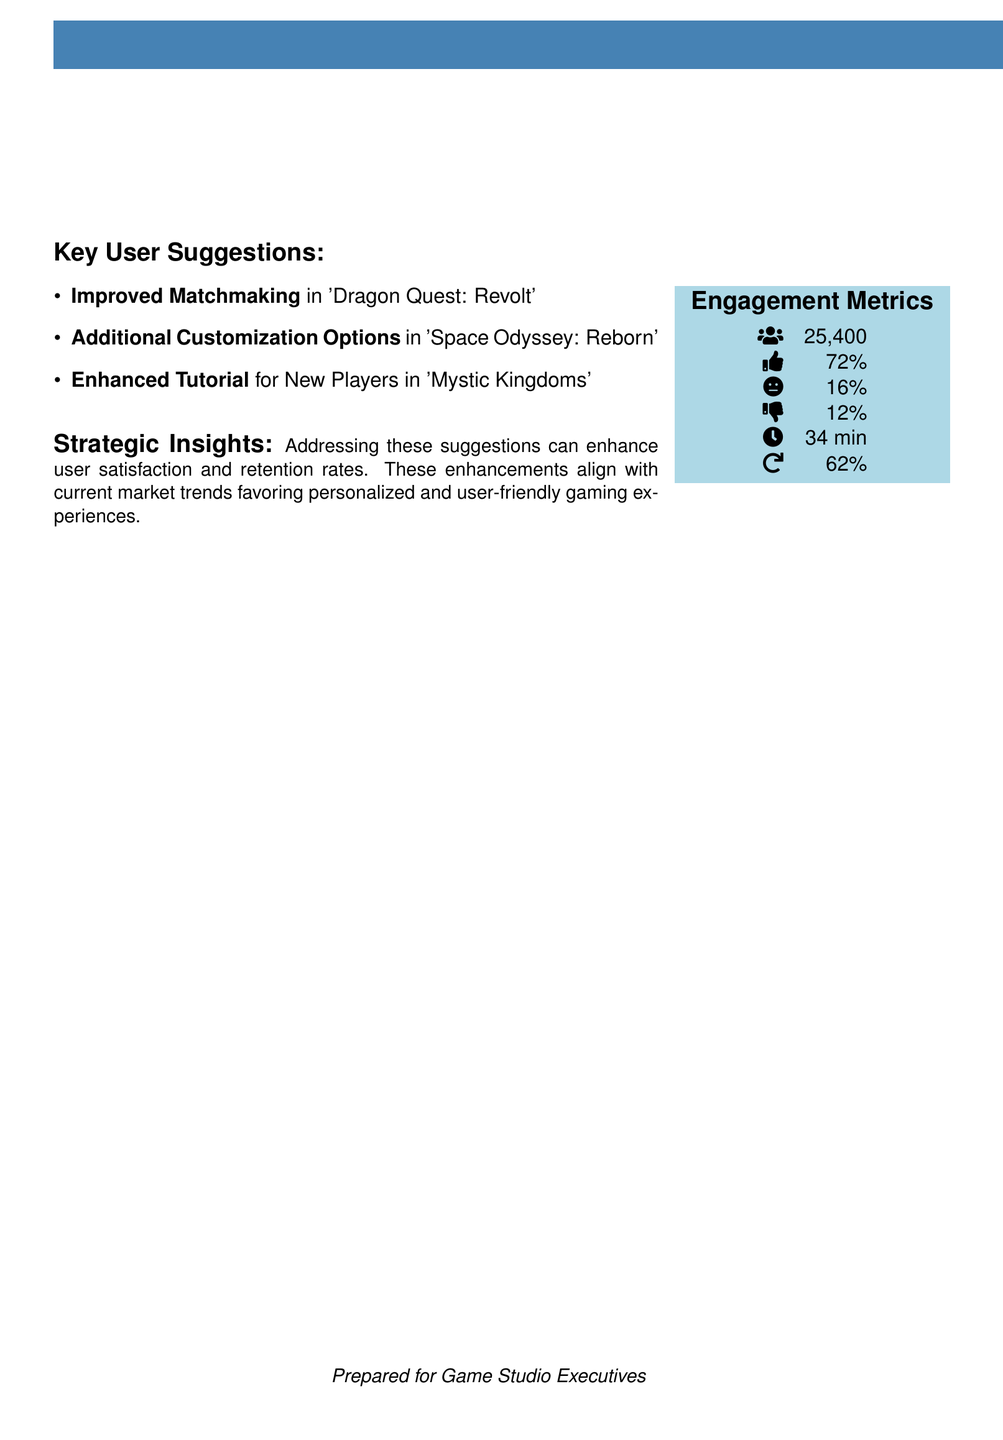What is the title of the report? The title of the report is presented at the top of the document, indicating the focus on user feedback.
Answer: User Feedback Report Q3 2023 How many users provided feedback? The number of users is listed under engagement metrics, representing the total participant count for feedback.
Answer: 25,400 What percentage of users liked the game? This percentage is shown in the engagement metrics, indicating user satisfaction levels.
Answer: 72% What is one key user suggestion related to 'Dragon Quest: Revolt'? The suggestions for improvement in the game are explicitly listed in the document.
Answer: Improved Matchmaking What engagement metric indicates session duration? This metric is specifically noted in the engagement section, reflecting the average time users spend on the game.
Answer: 34 min What is the percentage of neutral feedback? The document outlines user sentiment, including neutral feedback metrics in the engagement section.
Answer: 16% What is the suggested improvement for 'Mystic Kingdoms'? The suggested enhancements for particular games are detailed in the user suggestions section.
Answer: Enhanced Tutorial How do the suggested improvements align with market trends? The document provides strategic insights illustrating the relationship between user suggestions and current market preferences.
Answer: User-friendly gaming experiences What is the percentage of users who disliked the game? The dislike feedback is specifically mentioned in the engagement metrics, indicating the proportion of unsatisfied players.
Answer: 12% 